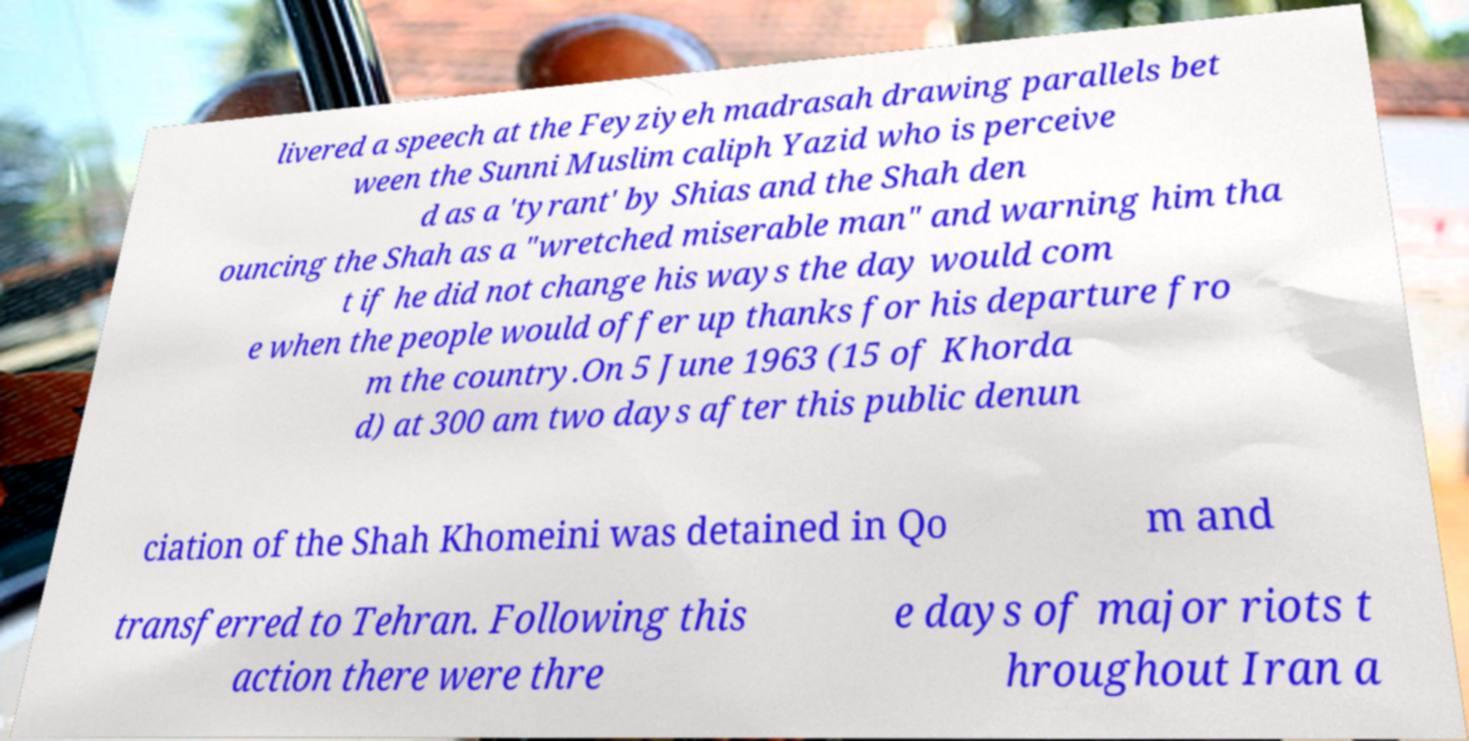Could you extract and type out the text from this image? livered a speech at the Feyziyeh madrasah drawing parallels bet ween the Sunni Muslim caliph Yazid who is perceive d as a 'tyrant' by Shias and the Shah den ouncing the Shah as a "wretched miserable man" and warning him tha t if he did not change his ways the day would com e when the people would offer up thanks for his departure fro m the country.On 5 June 1963 (15 of Khorda d) at 300 am two days after this public denun ciation of the Shah Khomeini was detained in Qo m and transferred to Tehran. Following this action there were thre e days of major riots t hroughout Iran a 